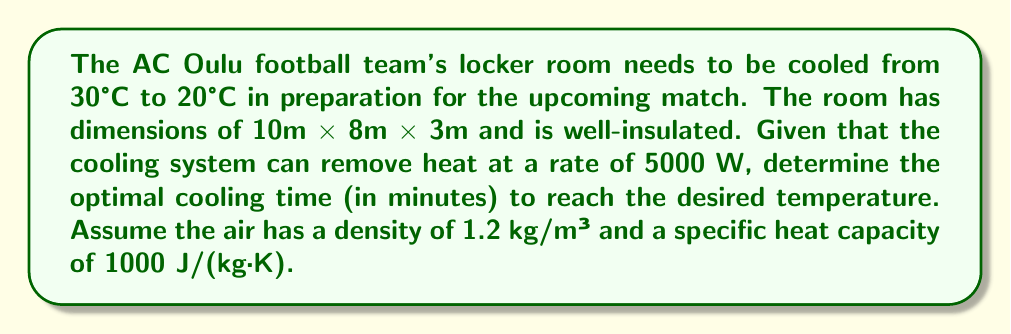Solve this math problem. To solve this problem, we'll use the heat equation and energy balance principles:

1. Calculate the volume of the locker room:
   $V = 10 \text{ m} \times 8 \text{ m} \times 3 \text{ m} = 240 \text{ m}^3$

2. Calculate the mass of air in the room:
   $m = \rho V = 1.2 \text{ kg/m}^3 \times 240 \text{ m}^3 = 288 \text{ kg}$

3. Calculate the energy needed to cool the room:
   $Q = mc\Delta T$
   Where:
   $m$ = mass of air
   $c$ = specific heat capacity of air
   $\Delta T$ = temperature change

   $Q = 288 \text{ kg} \times 1000 \text{ J/(kg·K)} \times (30°\text{C} - 20°\text{C})$
   $Q = 2,880,000 \text{ J}$

4. Calculate the time needed to remove this heat:
   $t = \frac{Q}{P}$
   Where:
   $Q$ = energy to be removed
   $P$ = power of the cooling system

   $t = \frac{2,880,000 \text{ J}}{5000 \text{ W}} = 576 \text{ s}$

5. Convert seconds to minutes:
   $576 \text{ s} \times \frac{1 \text{ min}}{60 \text{ s}} = 9.6 \text{ min}$

Therefore, the optimal cooling time is approximately 9.6 minutes.
Answer: 9.6 minutes 